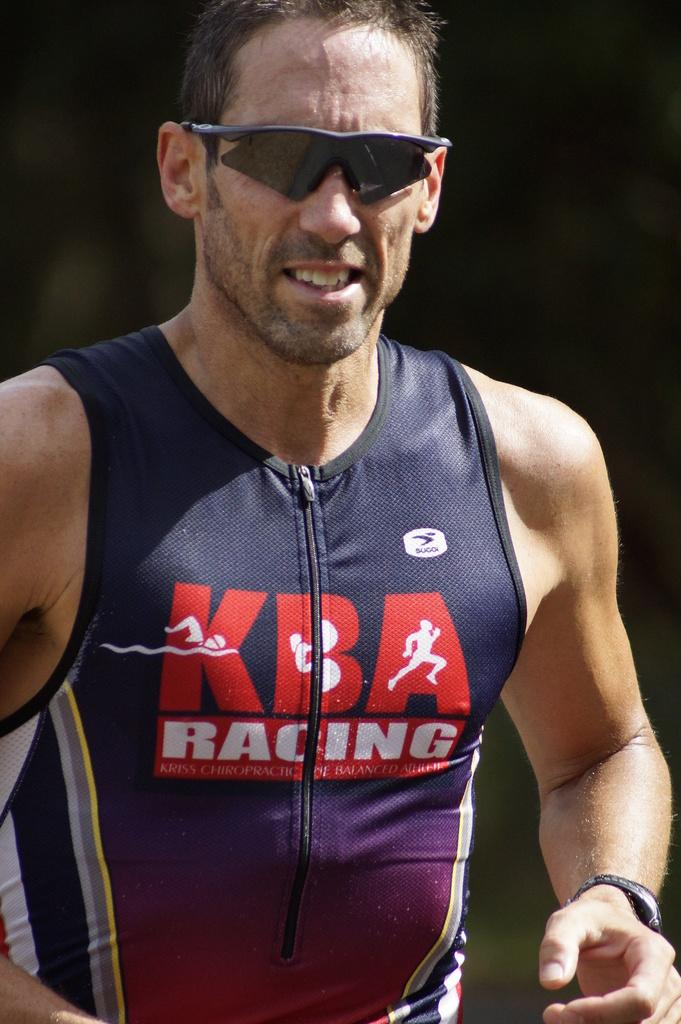<image>
Create a compact narrative representing the image presented. A man wearing a KBA Racing jersey has sunglasses on his face 